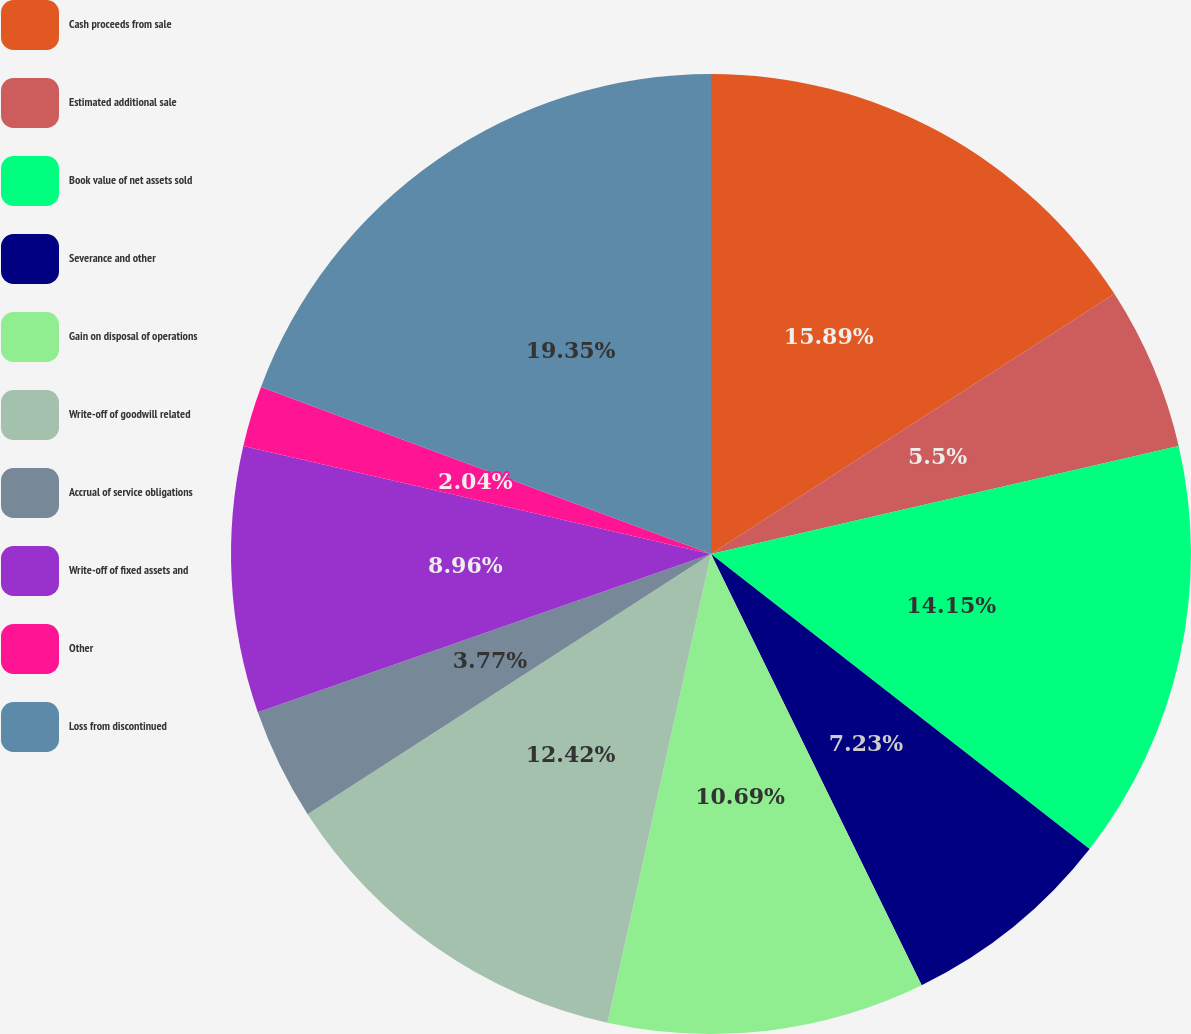Convert chart to OTSL. <chart><loc_0><loc_0><loc_500><loc_500><pie_chart><fcel>Cash proceeds from sale<fcel>Estimated additional sale<fcel>Book value of net assets sold<fcel>Severance and other<fcel>Gain on disposal of operations<fcel>Write-off of goodwill related<fcel>Accrual of service obligations<fcel>Write-off of fixed assets and<fcel>Other<fcel>Loss from discontinued<nl><fcel>15.88%<fcel>5.5%<fcel>14.15%<fcel>7.23%<fcel>10.69%<fcel>12.42%<fcel>3.77%<fcel>8.96%<fcel>2.04%<fcel>19.34%<nl></chart> 